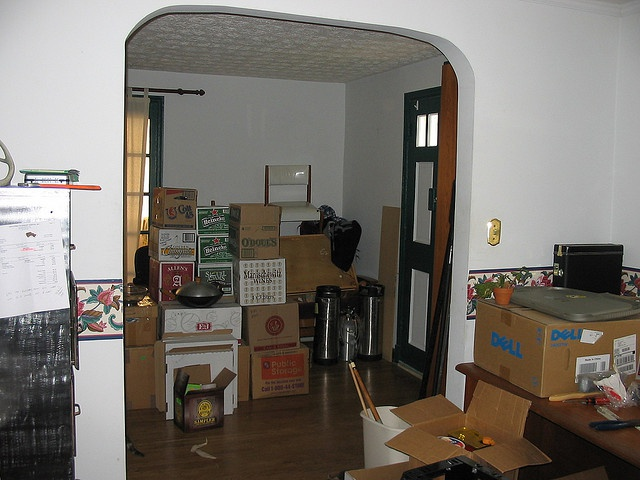Describe the objects in this image and their specific colors. I can see refrigerator in darkgray, black, lightgray, and gray tones, laptop in darkgray, black, and gray tones, chair in darkgray, gray, and black tones, potted plant in darkgray, brown, maroon, olive, and black tones, and book in darkgray, white, gray, and navy tones in this image. 